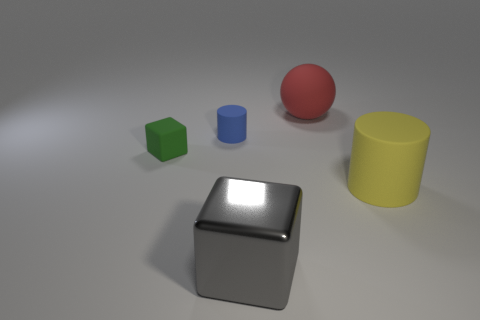Add 1 small red blocks. How many objects exist? 6 Subtract all yellow cylinders. Subtract all big shiny blocks. How many objects are left? 3 Add 2 red matte things. How many red matte things are left? 3 Add 4 small cylinders. How many small cylinders exist? 5 Subtract 1 blue cylinders. How many objects are left? 4 Subtract all cylinders. How many objects are left? 3 